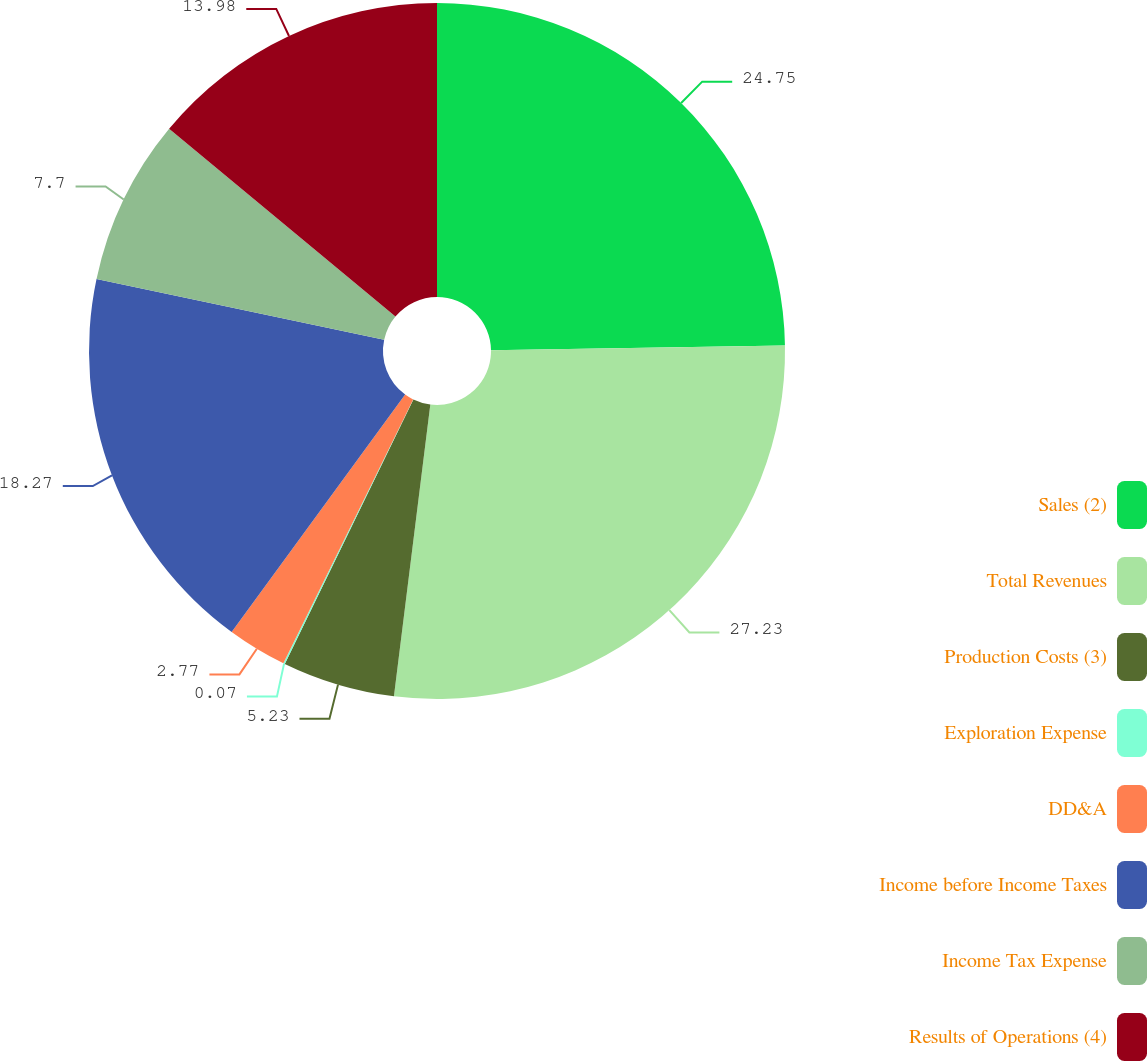Convert chart to OTSL. <chart><loc_0><loc_0><loc_500><loc_500><pie_chart><fcel>Sales (2)<fcel>Total Revenues<fcel>Production Costs (3)<fcel>Exploration Expense<fcel>DD&A<fcel>Income before Income Taxes<fcel>Income Tax Expense<fcel>Results of Operations (4)<nl><fcel>24.75%<fcel>27.22%<fcel>5.23%<fcel>0.07%<fcel>2.77%<fcel>18.27%<fcel>7.7%<fcel>13.98%<nl></chart> 